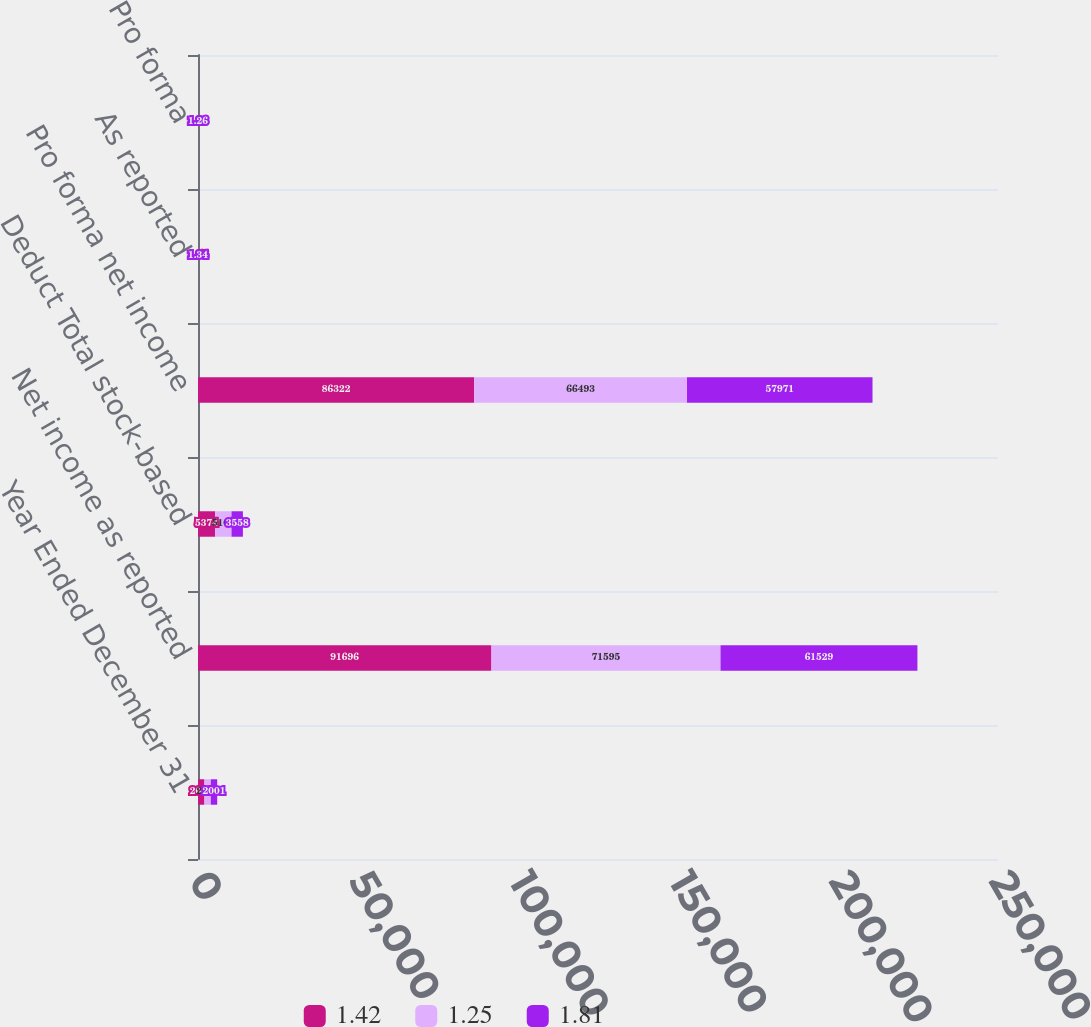Convert chart. <chart><loc_0><loc_0><loc_500><loc_500><stacked_bar_chart><ecel><fcel>Year Ended December 31<fcel>Net income as reported<fcel>Deduct Total stock-based<fcel>Pro forma net income<fcel>As reported<fcel>Pro forma<nl><fcel>1.42<fcel>2003<fcel>91696<fcel>5374<fcel>86322<fcel>1.95<fcel>1.83<nl><fcel>1.25<fcel>2002<fcel>71595<fcel>5102<fcel>66493<fcel>1.54<fcel>1.43<nl><fcel>1.81<fcel>2001<fcel>61529<fcel>3558<fcel>57971<fcel>1.34<fcel>1.26<nl></chart> 